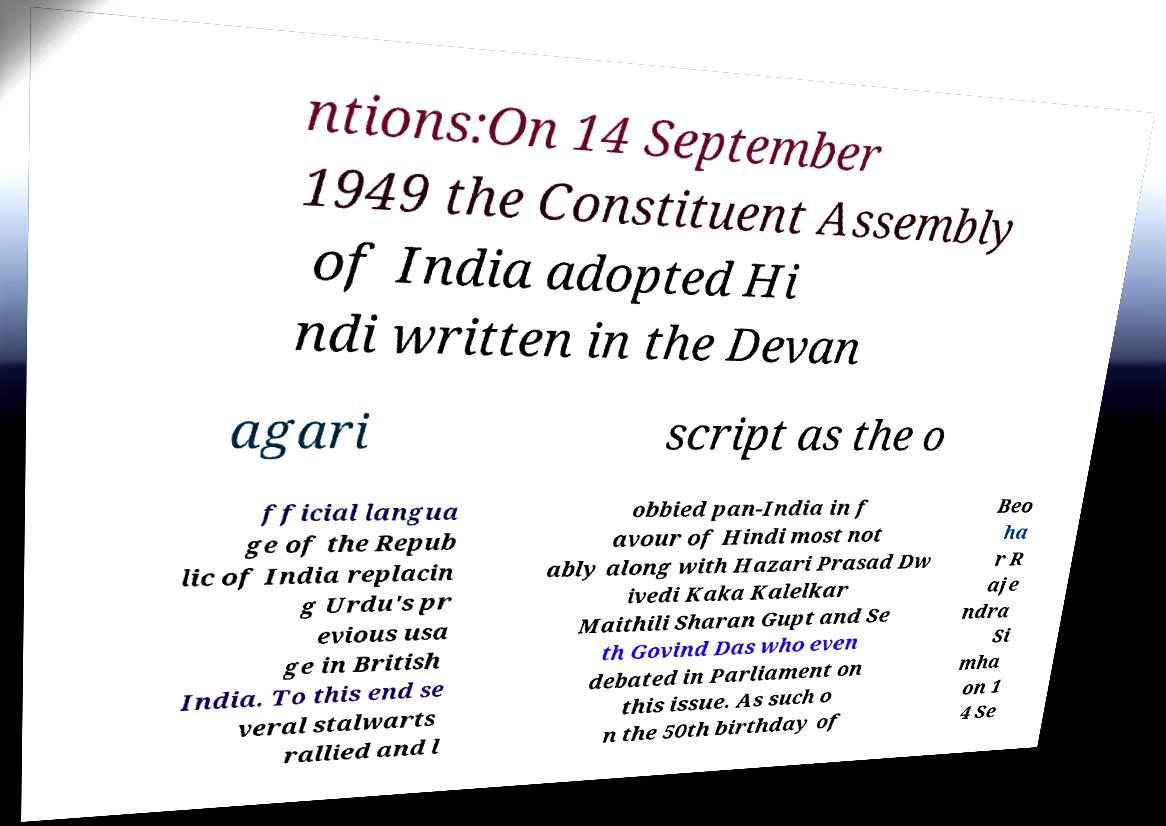There's text embedded in this image that I need extracted. Can you transcribe it verbatim? ntions:On 14 September 1949 the Constituent Assembly of India adopted Hi ndi written in the Devan agari script as the o fficial langua ge of the Repub lic of India replacin g Urdu's pr evious usa ge in British India. To this end se veral stalwarts rallied and l obbied pan-India in f avour of Hindi most not ably along with Hazari Prasad Dw ivedi Kaka Kalelkar Maithili Sharan Gupt and Se th Govind Das who even debated in Parliament on this issue. As such o n the 50th birthday of Beo ha r R aje ndra Si mha on 1 4 Se 